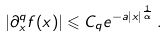Convert formula to latex. <formula><loc_0><loc_0><loc_500><loc_500>| \partial _ { x } ^ { q } f ( x ) | \leqslant C _ { q } e ^ { - a | x | ^ { \frac { 1 } { \alpha } } } \, .</formula> 